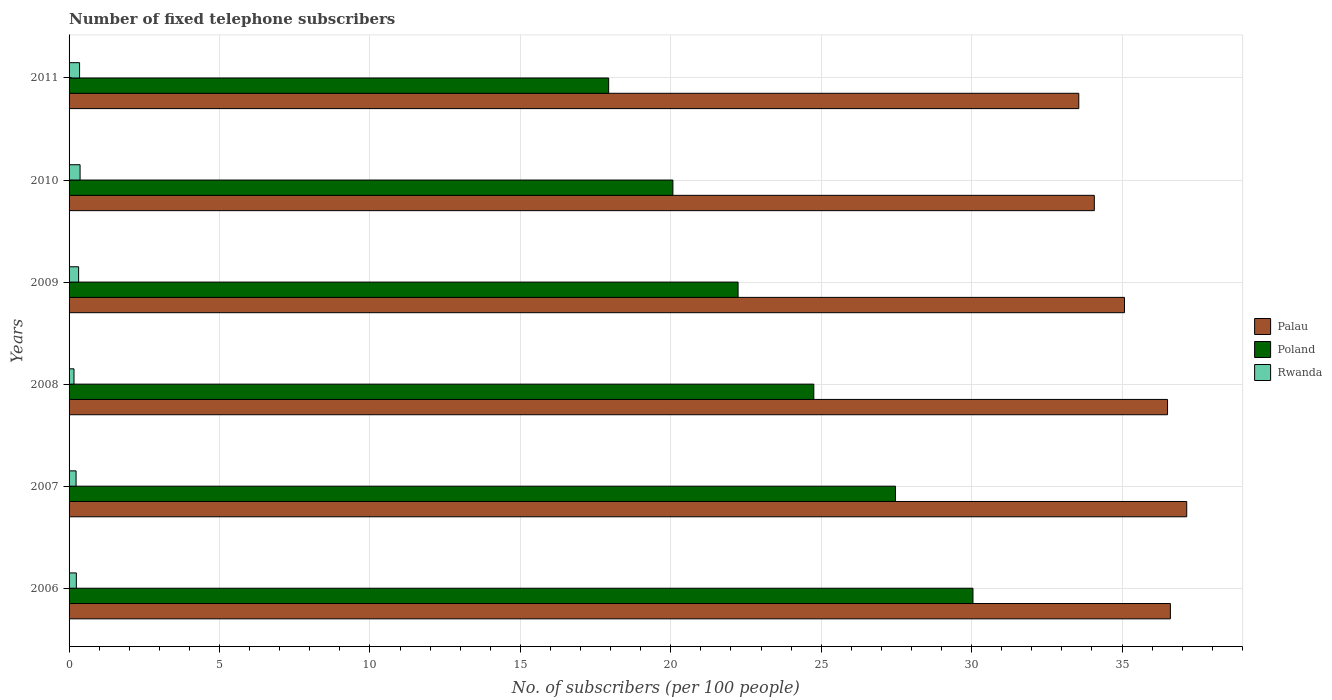How many different coloured bars are there?
Your answer should be compact. 3. How many groups of bars are there?
Your answer should be compact. 6. Are the number of bars per tick equal to the number of legend labels?
Provide a short and direct response. Yes. Are the number of bars on each tick of the Y-axis equal?
Your answer should be compact. Yes. How many bars are there on the 2nd tick from the bottom?
Give a very brief answer. 3. What is the number of fixed telephone subscribers in Rwanda in 2009?
Keep it short and to the point. 0.32. Across all years, what is the maximum number of fixed telephone subscribers in Rwanda?
Provide a succinct answer. 0.37. Across all years, what is the minimum number of fixed telephone subscribers in Poland?
Provide a succinct answer. 17.94. What is the total number of fixed telephone subscribers in Poland in the graph?
Your answer should be very brief. 142.52. What is the difference between the number of fixed telephone subscribers in Poland in 2007 and that in 2008?
Ensure brevity in your answer.  2.71. What is the difference between the number of fixed telephone subscribers in Poland in 2006 and the number of fixed telephone subscribers in Palau in 2011?
Offer a very short reply. -3.52. What is the average number of fixed telephone subscribers in Palau per year?
Your answer should be very brief. 35.5. In the year 2011, what is the difference between the number of fixed telephone subscribers in Palau and number of fixed telephone subscribers in Rwanda?
Give a very brief answer. 33.21. In how many years, is the number of fixed telephone subscribers in Palau greater than 35 ?
Provide a succinct answer. 4. What is the ratio of the number of fixed telephone subscribers in Poland in 2007 to that in 2009?
Keep it short and to the point. 1.24. What is the difference between the highest and the second highest number of fixed telephone subscribers in Palau?
Your answer should be compact. 0.54. What is the difference between the highest and the lowest number of fixed telephone subscribers in Palau?
Offer a very short reply. 3.59. Is the sum of the number of fixed telephone subscribers in Poland in 2006 and 2011 greater than the maximum number of fixed telephone subscribers in Rwanda across all years?
Provide a short and direct response. Yes. What does the 3rd bar from the top in 2009 represents?
Ensure brevity in your answer.  Palau. What does the 1st bar from the bottom in 2006 represents?
Offer a very short reply. Palau. Is it the case that in every year, the sum of the number of fixed telephone subscribers in Rwanda and number of fixed telephone subscribers in Palau is greater than the number of fixed telephone subscribers in Poland?
Your answer should be very brief. Yes. How many bars are there?
Your answer should be compact. 18. Are all the bars in the graph horizontal?
Offer a terse response. Yes. Are the values on the major ticks of X-axis written in scientific E-notation?
Your response must be concise. No. Does the graph contain any zero values?
Give a very brief answer. No. Where does the legend appear in the graph?
Your answer should be compact. Center right. How are the legend labels stacked?
Provide a succinct answer. Vertical. What is the title of the graph?
Offer a terse response. Number of fixed telephone subscribers. Does "Latin America(developing only)" appear as one of the legend labels in the graph?
Give a very brief answer. No. What is the label or title of the X-axis?
Keep it short and to the point. No. of subscribers (per 100 people). What is the No. of subscribers (per 100 people) of Palau in 2006?
Provide a short and direct response. 36.61. What is the No. of subscribers (per 100 people) in Poland in 2006?
Ensure brevity in your answer.  30.05. What is the No. of subscribers (per 100 people) in Rwanda in 2006?
Make the answer very short. 0.24. What is the No. of subscribers (per 100 people) in Palau in 2007?
Offer a very short reply. 37.15. What is the No. of subscribers (per 100 people) of Poland in 2007?
Your answer should be compact. 27.47. What is the No. of subscribers (per 100 people) in Rwanda in 2007?
Ensure brevity in your answer.  0.23. What is the No. of subscribers (per 100 people) in Palau in 2008?
Provide a short and direct response. 36.51. What is the No. of subscribers (per 100 people) in Poland in 2008?
Your answer should be compact. 24.76. What is the No. of subscribers (per 100 people) of Rwanda in 2008?
Give a very brief answer. 0.16. What is the No. of subscribers (per 100 people) of Palau in 2009?
Provide a succinct answer. 35.08. What is the No. of subscribers (per 100 people) in Poland in 2009?
Give a very brief answer. 22.24. What is the No. of subscribers (per 100 people) in Rwanda in 2009?
Keep it short and to the point. 0.32. What is the No. of subscribers (per 100 people) in Palau in 2010?
Offer a terse response. 34.08. What is the No. of subscribers (per 100 people) in Poland in 2010?
Make the answer very short. 20.07. What is the No. of subscribers (per 100 people) in Rwanda in 2010?
Keep it short and to the point. 0.37. What is the No. of subscribers (per 100 people) of Palau in 2011?
Make the answer very short. 33.56. What is the No. of subscribers (per 100 people) in Poland in 2011?
Provide a short and direct response. 17.94. What is the No. of subscribers (per 100 people) in Rwanda in 2011?
Your response must be concise. 0.35. Across all years, what is the maximum No. of subscribers (per 100 people) of Palau?
Provide a succinct answer. 37.15. Across all years, what is the maximum No. of subscribers (per 100 people) of Poland?
Offer a very short reply. 30.05. Across all years, what is the maximum No. of subscribers (per 100 people) of Rwanda?
Ensure brevity in your answer.  0.37. Across all years, what is the minimum No. of subscribers (per 100 people) of Palau?
Make the answer very short. 33.56. Across all years, what is the minimum No. of subscribers (per 100 people) of Poland?
Keep it short and to the point. 17.94. Across all years, what is the minimum No. of subscribers (per 100 people) in Rwanda?
Ensure brevity in your answer.  0.16. What is the total No. of subscribers (per 100 people) of Palau in the graph?
Offer a terse response. 213. What is the total No. of subscribers (per 100 people) of Poland in the graph?
Ensure brevity in your answer.  142.52. What is the total No. of subscribers (per 100 people) in Rwanda in the graph?
Your answer should be compact. 1.67. What is the difference between the No. of subscribers (per 100 people) of Palau in 2006 and that in 2007?
Provide a short and direct response. -0.54. What is the difference between the No. of subscribers (per 100 people) of Poland in 2006 and that in 2007?
Your answer should be very brief. 2.58. What is the difference between the No. of subscribers (per 100 people) of Rwanda in 2006 and that in 2007?
Ensure brevity in your answer.  0.01. What is the difference between the No. of subscribers (per 100 people) of Palau in 2006 and that in 2008?
Your answer should be compact. 0.09. What is the difference between the No. of subscribers (per 100 people) of Poland in 2006 and that in 2008?
Give a very brief answer. 5.29. What is the difference between the No. of subscribers (per 100 people) in Rwanda in 2006 and that in 2008?
Make the answer very short. 0.08. What is the difference between the No. of subscribers (per 100 people) of Palau in 2006 and that in 2009?
Ensure brevity in your answer.  1.53. What is the difference between the No. of subscribers (per 100 people) of Poland in 2006 and that in 2009?
Your answer should be compact. 7.81. What is the difference between the No. of subscribers (per 100 people) of Rwanda in 2006 and that in 2009?
Ensure brevity in your answer.  -0.08. What is the difference between the No. of subscribers (per 100 people) in Palau in 2006 and that in 2010?
Your answer should be very brief. 2.53. What is the difference between the No. of subscribers (per 100 people) of Poland in 2006 and that in 2010?
Provide a succinct answer. 9.97. What is the difference between the No. of subscribers (per 100 people) of Rwanda in 2006 and that in 2010?
Your answer should be compact. -0.12. What is the difference between the No. of subscribers (per 100 people) of Palau in 2006 and that in 2011?
Ensure brevity in your answer.  3.04. What is the difference between the No. of subscribers (per 100 people) in Poland in 2006 and that in 2011?
Provide a succinct answer. 12.11. What is the difference between the No. of subscribers (per 100 people) of Rwanda in 2006 and that in 2011?
Make the answer very short. -0.11. What is the difference between the No. of subscribers (per 100 people) of Palau in 2007 and that in 2008?
Provide a succinct answer. 0.64. What is the difference between the No. of subscribers (per 100 people) of Poland in 2007 and that in 2008?
Your response must be concise. 2.71. What is the difference between the No. of subscribers (per 100 people) of Rwanda in 2007 and that in 2008?
Provide a succinct answer. 0.07. What is the difference between the No. of subscribers (per 100 people) of Palau in 2007 and that in 2009?
Offer a terse response. 2.07. What is the difference between the No. of subscribers (per 100 people) of Poland in 2007 and that in 2009?
Your response must be concise. 5.23. What is the difference between the No. of subscribers (per 100 people) of Rwanda in 2007 and that in 2009?
Give a very brief answer. -0.08. What is the difference between the No. of subscribers (per 100 people) in Palau in 2007 and that in 2010?
Give a very brief answer. 3.07. What is the difference between the No. of subscribers (per 100 people) of Poland in 2007 and that in 2010?
Give a very brief answer. 7.4. What is the difference between the No. of subscribers (per 100 people) of Rwanda in 2007 and that in 2010?
Offer a very short reply. -0.13. What is the difference between the No. of subscribers (per 100 people) in Palau in 2007 and that in 2011?
Make the answer very short. 3.59. What is the difference between the No. of subscribers (per 100 people) of Poland in 2007 and that in 2011?
Make the answer very short. 9.53. What is the difference between the No. of subscribers (per 100 people) in Rwanda in 2007 and that in 2011?
Your answer should be compact. -0.12. What is the difference between the No. of subscribers (per 100 people) of Palau in 2008 and that in 2009?
Provide a short and direct response. 1.43. What is the difference between the No. of subscribers (per 100 people) in Poland in 2008 and that in 2009?
Keep it short and to the point. 2.52. What is the difference between the No. of subscribers (per 100 people) of Rwanda in 2008 and that in 2009?
Your answer should be very brief. -0.15. What is the difference between the No. of subscribers (per 100 people) in Palau in 2008 and that in 2010?
Keep it short and to the point. 2.43. What is the difference between the No. of subscribers (per 100 people) in Poland in 2008 and that in 2010?
Your response must be concise. 4.68. What is the difference between the No. of subscribers (per 100 people) of Rwanda in 2008 and that in 2010?
Make the answer very short. -0.2. What is the difference between the No. of subscribers (per 100 people) in Palau in 2008 and that in 2011?
Provide a succinct answer. 2.95. What is the difference between the No. of subscribers (per 100 people) in Poland in 2008 and that in 2011?
Keep it short and to the point. 6.82. What is the difference between the No. of subscribers (per 100 people) of Rwanda in 2008 and that in 2011?
Keep it short and to the point. -0.18. What is the difference between the No. of subscribers (per 100 people) of Poland in 2009 and that in 2010?
Provide a short and direct response. 2.17. What is the difference between the No. of subscribers (per 100 people) in Rwanda in 2009 and that in 2010?
Your response must be concise. -0.05. What is the difference between the No. of subscribers (per 100 people) of Palau in 2009 and that in 2011?
Provide a short and direct response. 1.52. What is the difference between the No. of subscribers (per 100 people) of Poland in 2009 and that in 2011?
Provide a succinct answer. 4.3. What is the difference between the No. of subscribers (per 100 people) of Rwanda in 2009 and that in 2011?
Ensure brevity in your answer.  -0.03. What is the difference between the No. of subscribers (per 100 people) in Palau in 2010 and that in 2011?
Provide a short and direct response. 0.52. What is the difference between the No. of subscribers (per 100 people) of Poland in 2010 and that in 2011?
Offer a very short reply. 2.13. What is the difference between the No. of subscribers (per 100 people) in Rwanda in 2010 and that in 2011?
Offer a very short reply. 0.02. What is the difference between the No. of subscribers (per 100 people) of Palau in 2006 and the No. of subscribers (per 100 people) of Poland in 2007?
Keep it short and to the point. 9.14. What is the difference between the No. of subscribers (per 100 people) in Palau in 2006 and the No. of subscribers (per 100 people) in Rwanda in 2007?
Keep it short and to the point. 36.38. What is the difference between the No. of subscribers (per 100 people) of Poland in 2006 and the No. of subscribers (per 100 people) of Rwanda in 2007?
Keep it short and to the point. 29.81. What is the difference between the No. of subscribers (per 100 people) of Palau in 2006 and the No. of subscribers (per 100 people) of Poland in 2008?
Provide a short and direct response. 11.85. What is the difference between the No. of subscribers (per 100 people) of Palau in 2006 and the No. of subscribers (per 100 people) of Rwanda in 2008?
Offer a very short reply. 36.44. What is the difference between the No. of subscribers (per 100 people) of Poland in 2006 and the No. of subscribers (per 100 people) of Rwanda in 2008?
Your answer should be very brief. 29.88. What is the difference between the No. of subscribers (per 100 people) of Palau in 2006 and the No. of subscribers (per 100 people) of Poland in 2009?
Provide a short and direct response. 14.37. What is the difference between the No. of subscribers (per 100 people) in Palau in 2006 and the No. of subscribers (per 100 people) in Rwanda in 2009?
Make the answer very short. 36.29. What is the difference between the No. of subscribers (per 100 people) in Poland in 2006 and the No. of subscribers (per 100 people) in Rwanda in 2009?
Offer a terse response. 29.73. What is the difference between the No. of subscribers (per 100 people) of Palau in 2006 and the No. of subscribers (per 100 people) of Poland in 2010?
Give a very brief answer. 16.54. What is the difference between the No. of subscribers (per 100 people) of Palau in 2006 and the No. of subscribers (per 100 people) of Rwanda in 2010?
Offer a very short reply. 36.24. What is the difference between the No. of subscribers (per 100 people) of Poland in 2006 and the No. of subscribers (per 100 people) of Rwanda in 2010?
Give a very brief answer. 29.68. What is the difference between the No. of subscribers (per 100 people) in Palau in 2006 and the No. of subscribers (per 100 people) in Poland in 2011?
Offer a very short reply. 18.67. What is the difference between the No. of subscribers (per 100 people) in Palau in 2006 and the No. of subscribers (per 100 people) in Rwanda in 2011?
Your response must be concise. 36.26. What is the difference between the No. of subscribers (per 100 people) in Poland in 2006 and the No. of subscribers (per 100 people) in Rwanda in 2011?
Keep it short and to the point. 29.7. What is the difference between the No. of subscribers (per 100 people) of Palau in 2007 and the No. of subscribers (per 100 people) of Poland in 2008?
Provide a succinct answer. 12.4. What is the difference between the No. of subscribers (per 100 people) in Palau in 2007 and the No. of subscribers (per 100 people) in Rwanda in 2008?
Provide a short and direct response. 36.99. What is the difference between the No. of subscribers (per 100 people) of Poland in 2007 and the No. of subscribers (per 100 people) of Rwanda in 2008?
Provide a succinct answer. 27.31. What is the difference between the No. of subscribers (per 100 people) in Palau in 2007 and the No. of subscribers (per 100 people) in Poland in 2009?
Your answer should be compact. 14.91. What is the difference between the No. of subscribers (per 100 people) of Palau in 2007 and the No. of subscribers (per 100 people) of Rwanda in 2009?
Give a very brief answer. 36.83. What is the difference between the No. of subscribers (per 100 people) of Poland in 2007 and the No. of subscribers (per 100 people) of Rwanda in 2009?
Provide a short and direct response. 27.15. What is the difference between the No. of subscribers (per 100 people) of Palau in 2007 and the No. of subscribers (per 100 people) of Poland in 2010?
Give a very brief answer. 17.08. What is the difference between the No. of subscribers (per 100 people) in Palau in 2007 and the No. of subscribers (per 100 people) in Rwanda in 2010?
Your answer should be very brief. 36.78. What is the difference between the No. of subscribers (per 100 people) in Poland in 2007 and the No. of subscribers (per 100 people) in Rwanda in 2010?
Provide a short and direct response. 27.1. What is the difference between the No. of subscribers (per 100 people) of Palau in 2007 and the No. of subscribers (per 100 people) of Poland in 2011?
Your answer should be very brief. 19.21. What is the difference between the No. of subscribers (per 100 people) of Palau in 2007 and the No. of subscribers (per 100 people) of Rwanda in 2011?
Your answer should be compact. 36.8. What is the difference between the No. of subscribers (per 100 people) in Poland in 2007 and the No. of subscribers (per 100 people) in Rwanda in 2011?
Make the answer very short. 27.12. What is the difference between the No. of subscribers (per 100 people) in Palau in 2008 and the No. of subscribers (per 100 people) in Poland in 2009?
Make the answer very short. 14.28. What is the difference between the No. of subscribers (per 100 people) in Palau in 2008 and the No. of subscribers (per 100 people) in Rwanda in 2009?
Make the answer very short. 36.2. What is the difference between the No. of subscribers (per 100 people) in Poland in 2008 and the No. of subscribers (per 100 people) in Rwanda in 2009?
Keep it short and to the point. 24.44. What is the difference between the No. of subscribers (per 100 people) in Palau in 2008 and the No. of subscribers (per 100 people) in Poland in 2010?
Keep it short and to the point. 16.44. What is the difference between the No. of subscribers (per 100 people) of Palau in 2008 and the No. of subscribers (per 100 people) of Rwanda in 2010?
Make the answer very short. 36.15. What is the difference between the No. of subscribers (per 100 people) of Poland in 2008 and the No. of subscribers (per 100 people) of Rwanda in 2010?
Your answer should be compact. 24.39. What is the difference between the No. of subscribers (per 100 people) in Palau in 2008 and the No. of subscribers (per 100 people) in Poland in 2011?
Keep it short and to the point. 18.58. What is the difference between the No. of subscribers (per 100 people) in Palau in 2008 and the No. of subscribers (per 100 people) in Rwanda in 2011?
Give a very brief answer. 36.16. What is the difference between the No. of subscribers (per 100 people) in Poland in 2008 and the No. of subscribers (per 100 people) in Rwanda in 2011?
Ensure brevity in your answer.  24.41. What is the difference between the No. of subscribers (per 100 people) in Palau in 2009 and the No. of subscribers (per 100 people) in Poland in 2010?
Offer a terse response. 15.01. What is the difference between the No. of subscribers (per 100 people) of Palau in 2009 and the No. of subscribers (per 100 people) of Rwanda in 2010?
Offer a very short reply. 34.72. What is the difference between the No. of subscribers (per 100 people) in Poland in 2009 and the No. of subscribers (per 100 people) in Rwanda in 2010?
Your answer should be compact. 21.87. What is the difference between the No. of subscribers (per 100 people) in Palau in 2009 and the No. of subscribers (per 100 people) in Poland in 2011?
Offer a terse response. 17.14. What is the difference between the No. of subscribers (per 100 people) in Palau in 2009 and the No. of subscribers (per 100 people) in Rwanda in 2011?
Your answer should be compact. 34.73. What is the difference between the No. of subscribers (per 100 people) of Poland in 2009 and the No. of subscribers (per 100 people) of Rwanda in 2011?
Your response must be concise. 21.89. What is the difference between the No. of subscribers (per 100 people) in Palau in 2010 and the No. of subscribers (per 100 people) in Poland in 2011?
Provide a short and direct response. 16.14. What is the difference between the No. of subscribers (per 100 people) in Palau in 2010 and the No. of subscribers (per 100 people) in Rwanda in 2011?
Offer a terse response. 33.73. What is the difference between the No. of subscribers (per 100 people) of Poland in 2010 and the No. of subscribers (per 100 people) of Rwanda in 2011?
Your response must be concise. 19.72. What is the average No. of subscribers (per 100 people) in Palau per year?
Provide a succinct answer. 35.5. What is the average No. of subscribers (per 100 people) of Poland per year?
Your answer should be compact. 23.75. What is the average No. of subscribers (per 100 people) in Rwanda per year?
Give a very brief answer. 0.28. In the year 2006, what is the difference between the No. of subscribers (per 100 people) of Palau and No. of subscribers (per 100 people) of Poland?
Provide a succinct answer. 6.56. In the year 2006, what is the difference between the No. of subscribers (per 100 people) in Palau and No. of subscribers (per 100 people) in Rwanda?
Give a very brief answer. 36.37. In the year 2006, what is the difference between the No. of subscribers (per 100 people) in Poland and No. of subscribers (per 100 people) in Rwanda?
Ensure brevity in your answer.  29.8. In the year 2007, what is the difference between the No. of subscribers (per 100 people) in Palau and No. of subscribers (per 100 people) in Poland?
Provide a short and direct response. 9.68. In the year 2007, what is the difference between the No. of subscribers (per 100 people) of Palau and No. of subscribers (per 100 people) of Rwanda?
Provide a succinct answer. 36.92. In the year 2007, what is the difference between the No. of subscribers (per 100 people) in Poland and No. of subscribers (per 100 people) in Rwanda?
Your answer should be compact. 27.24. In the year 2008, what is the difference between the No. of subscribers (per 100 people) of Palau and No. of subscribers (per 100 people) of Poland?
Provide a short and direct response. 11.76. In the year 2008, what is the difference between the No. of subscribers (per 100 people) of Palau and No. of subscribers (per 100 people) of Rwanda?
Keep it short and to the point. 36.35. In the year 2008, what is the difference between the No. of subscribers (per 100 people) of Poland and No. of subscribers (per 100 people) of Rwanda?
Make the answer very short. 24.59. In the year 2009, what is the difference between the No. of subscribers (per 100 people) of Palau and No. of subscribers (per 100 people) of Poland?
Keep it short and to the point. 12.84. In the year 2009, what is the difference between the No. of subscribers (per 100 people) in Palau and No. of subscribers (per 100 people) in Rwanda?
Provide a short and direct response. 34.76. In the year 2009, what is the difference between the No. of subscribers (per 100 people) in Poland and No. of subscribers (per 100 people) in Rwanda?
Provide a succinct answer. 21.92. In the year 2010, what is the difference between the No. of subscribers (per 100 people) of Palau and No. of subscribers (per 100 people) of Poland?
Keep it short and to the point. 14.01. In the year 2010, what is the difference between the No. of subscribers (per 100 people) in Palau and No. of subscribers (per 100 people) in Rwanda?
Offer a terse response. 33.71. In the year 2010, what is the difference between the No. of subscribers (per 100 people) of Poland and No. of subscribers (per 100 people) of Rwanda?
Keep it short and to the point. 19.71. In the year 2011, what is the difference between the No. of subscribers (per 100 people) of Palau and No. of subscribers (per 100 people) of Poland?
Offer a terse response. 15.63. In the year 2011, what is the difference between the No. of subscribers (per 100 people) in Palau and No. of subscribers (per 100 people) in Rwanda?
Your answer should be very brief. 33.21. In the year 2011, what is the difference between the No. of subscribers (per 100 people) of Poland and No. of subscribers (per 100 people) of Rwanda?
Offer a very short reply. 17.59. What is the ratio of the No. of subscribers (per 100 people) in Palau in 2006 to that in 2007?
Provide a succinct answer. 0.99. What is the ratio of the No. of subscribers (per 100 people) of Poland in 2006 to that in 2007?
Keep it short and to the point. 1.09. What is the ratio of the No. of subscribers (per 100 people) of Rwanda in 2006 to that in 2007?
Make the answer very short. 1.04. What is the ratio of the No. of subscribers (per 100 people) in Poland in 2006 to that in 2008?
Your answer should be very brief. 1.21. What is the ratio of the No. of subscribers (per 100 people) in Rwanda in 2006 to that in 2008?
Give a very brief answer. 1.47. What is the ratio of the No. of subscribers (per 100 people) of Palau in 2006 to that in 2009?
Provide a succinct answer. 1.04. What is the ratio of the No. of subscribers (per 100 people) of Poland in 2006 to that in 2009?
Provide a succinct answer. 1.35. What is the ratio of the No. of subscribers (per 100 people) of Rwanda in 2006 to that in 2009?
Offer a very short reply. 0.76. What is the ratio of the No. of subscribers (per 100 people) of Palau in 2006 to that in 2010?
Your answer should be compact. 1.07. What is the ratio of the No. of subscribers (per 100 people) of Poland in 2006 to that in 2010?
Keep it short and to the point. 1.5. What is the ratio of the No. of subscribers (per 100 people) of Rwanda in 2006 to that in 2010?
Your response must be concise. 0.66. What is the ratio of the No. of subscribers (per 100 people) of Palau in 2006 to that in 2011?
Keep it short and to the point. 1.09. What is the ratio of the No. of subscribers (per 100 people) of Poland in 2006 to that in 2011?
Make the answer very short. 1.68. What is the ratio of the No. of subscribers (per 100 people) of Rwanda in 2006 to that in 2011?
Keep it short and to the point. 0.69. What is the ratio of the No. of subscribers (per 100 people) of Palau in 2007 to that in 2008?
Give a very brief answer. 1.02. What is the ratio of the No. of subscribers (per 100 people) of Poland in 2007 to that in 2008?
Make the answer very short. 1.11. What is the ratio of the No. of subscribers (per 100 people) in Rwanda in 2007 to that in 2008?
Make the answer very short. 1.42. What is the ratio of the No. of subscribers (per 100 people) in Palau in 2007 to that in 2009?
Provide a short and direct response. 1.06. What is the ratio of the No. of subscribers (per 100 people) in Poland in 2007 to that in 2009?
Offer a very short reply. 1.24. What is the ratio of the No. of subscribers (per 100 people) of Rwanda in 2007 to that in 2009?
Your answer should be very brief. 0.73. What is the ratio of the No. of subscribers (per 100 people) in Palau in 2007 to that in 2010?
Provide a short and direct response. 1.09. What is the ratio of the No. of subscribers (per 100 people) in Poland in 2007 to that in 2010?
Provide a succinct answer. 1.37. What is the ratio of the No. of subscribers (per 100 people) of Rwanda in 2007 to that in 2010?
Provide a short and direct response. 0.64. What is the ratio of the No. of subscribers (per 100 people) in Palau in 2007 to that in 2011?
Provide a short and direct response. 1.11. What is the ratio of the No. of subscribers (per 100 people) of Poland in 2007 to that in 2011?
Offer a terse response. 1.53. What is the ratio of the No. of subscribers (per 100 people) in Rwanda in 2007 to that in 2011?
Give a very brief answer. 0.67. What is the ratio of the No. of subscribers (per 100 people) of Palau in 2008 to that in 2009?
Provide a succinct answer. 1.04. What is the ratio of the No. of subscribers (per 100 people) of Poland in 2008 to that in 2009?
Your answer should be compact. 1.11. What is the ratio of the No. of subscribers (per 100 people) of Rwanda in 2008 to that in 2009?
Provide a short and direct response. 0.52. What is the ratio of the No. of subscribers (per 100 people) in Palau in 2008 to that in 2010?
Your answer should be very brief. 1.07. What is the ratio of the No. of subscribers (per 100 people) of Poland in 2008 to that in 2010?
Your answer should be compact. 1.23. What is the ratio of the No. of subscribers (per 100 people) of Rwanda in 2008 to that in 2010?
Your answer should be very brief. 0.45. What is the ratio of the No. of subscribers (per 100 people) in Palau in 2008 to that in 2011?
Your answer should be compact. 1.09. What is the ratio of the No. of subscribers (per 100 people) of Poland in 2008 to that in 2011?
Provide a succinct answer. 1.38. What is the ratio of the No. of subscribers (per 100 people) in Rwanda in 2008 to that in 2011?
Provide a short and direct response. 0.47. What is the ratio of the No. of subscribers (per 100 people) of Palau in 2009 to that in 2010?
Ensure brevity in your answer.  1.03. What is the ratio of the No. of subscribers (per 100 people) of Poland in 2009 to that in 2010?
Your response must be concise. 1.11. What is the ratio of the No. of subscribers (per 100 people) of Rwanda in 2009 to that in 2010?
Make the answer very short. 0.87. What is the ratio of the No. of subscribers (per 100 people) in Palau in 2009 to that in 2011?
Make the answer very short. 1.05. What is the ratio of the No. of subscribers (per 100 people) in Poland in 2009 to that in 2011?
Give a very brief answer. 1.24. What is the ratio of the No. of subscribers (per 100 people) in Rwanda in 2009 to that in 2011?
Provide a succinct answer. 0.91. What is the ratio of the No. of subscribers (per 100 people) in Palau in 2010 to that in 2011?
Provide a succinct answer. 1.02. What is the ratio of the No. of subscribers (per 100 people) of Poland in 2010 to that in 2011?
Ensure brevity in your answer.  1.12. What is the ratio of the No. of subscribers (per 100 people) in Rwanda in 2010 to that in 2011?
Provide a short and direct response. 1.05. What is the difference between the highest and the second highest No. of subscribers (per 100 people) of Palau?
Your answer should be compact. 0.54. What is the difference between the highest and the second highest No. of subscribers (per 100 people) of Poland?
Your answer should be compact. 2.58. What is the difference between the highest and the second highest No. of subscribers (per 100 people) of Rwanda?
Keep it short and to the point. 0.02. What is the difference between the highest and the lowest No. of subscribers (per 100 people) in Palau?
Make the answer very short. 3.59. What is the difference between the highest and the lowest No. of subscribers (per 100 people) of Poland?
Give a very brief answer. 12.11. What is the difference between the highest and the lowest No. of subscribers (per 100 people) of Rwanda?
Give a very brief answer. 0.2. 